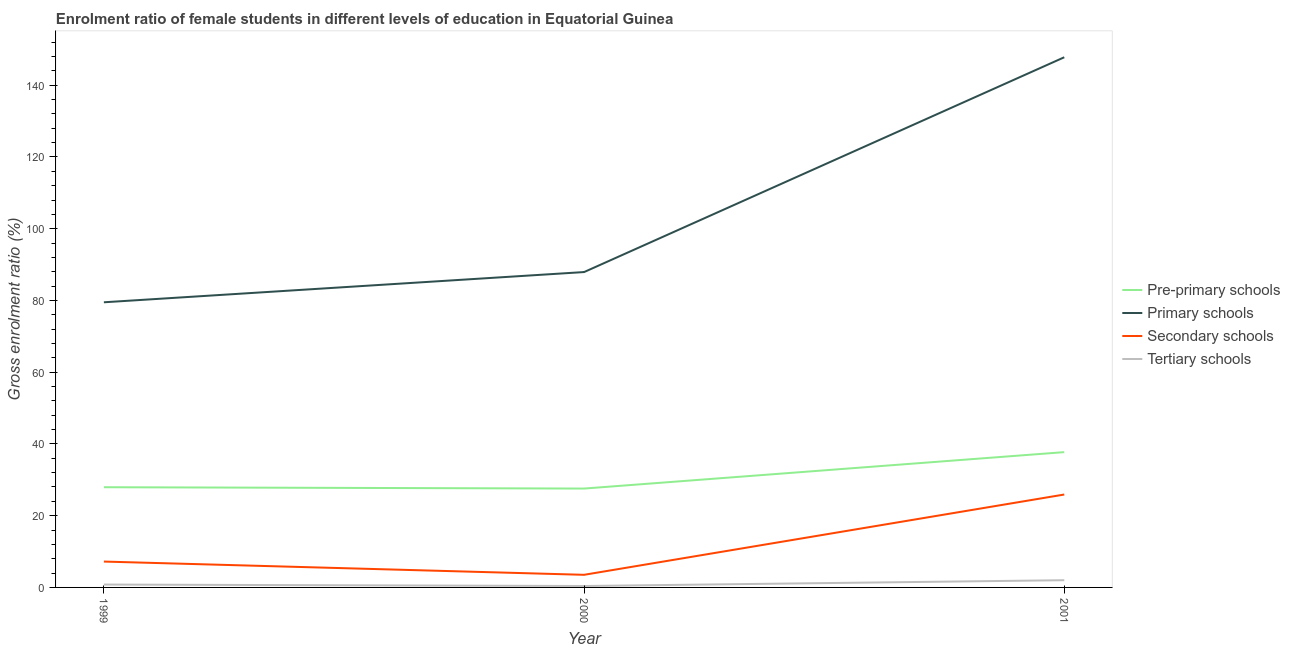What is the gross enrolment ratio(male) in secondary schools in 2000?
Offer a terse response. 3.52. Across all years, what is the maximum gross enrolment ratio(male) in tertiary schools?
Provide a short and direct response. 2.01. Across all years, what is the minimum gross enrolment ratio(male) in secondary schools?
Keep it short and to the point. 3.52. In which year was the gross enrolment ratio(male) in primary schools minimum?
Give a very brief answer. 1999. What is the total gross enrolment ratio(male) in pre-primary schools in the graph?
Keep it short and to the point. 93.21. What is the difference between the gross enrolment ratio(male) in pre-primary schools in 1999 and that in 2000?
Your response must be concise. 0.38. What is the difference between the gross enrolment ratio(male) in secondary schools in 2000 and the gross enrolment ratio(male) in pre-primary schools in 1999?
Keep it short and to the point. -24.42. What is the average gross enrolment ratio(male) in secondary schools per year?
Provide a succinct answer. 12.21. In the year 2001, what is the difference between the gross enrolment ratio(male) in primary schools and gross enrolment ratio(male) in secondary schools?
Offer a terse response. 121.9. In how many years, is the gross enrolment ratio(male) in tertiary schools greater than 136 %?
Ensure brevity in your answer.  0. What is the ratio of the gross enrolment ratio(male) in primary schools in 1999 to that in 2000?
Make the answer very short. 0.9. Is the gross enrolment ratio(male) in secondary schools in 2000 less than that in 2001?
Give a very brief answer. Yes. What is the difference between the highest and the second highest gross enrolment ratio(male) in pre-primary schools?
Your answer should be very brief. 9.78. What is the difference between the highest and the lowest gross enrolment ratio(male) in tertiary schools?
Keep it short and to the point. 1.62. In how many years, is the gross enrolment ratio(male) in secondary schools greater than the average gross enrolment ratio(male) in secondary schools taken over all years?
Ensure brevity in your answer.  1. Is it the case that in every year, the sum of the gross enrolment ratio(male) in primary schools and gross enrolment ratio(male) in secondary schools is greater than the sum of gross enrolment ratio(male) in tertiary schools and gross enrolment ratio(male) in pre-primary schools?
Offer a terse response. Yes. Is it the case that in every year, the sum of the gross enrolment ratio(male) in pre-primary schools and gross enrolment ratio(male) in primary schools is greater than the gross enrolment ratio(male) in secondary schools?
Give a very brief answer. Yes. Is the gross enrolment ratio(male) in tertiary schools strictly less than the gross enrolment ratio(male) in pre-primary schools over the years?
Provide a short and direct response. Yes. How many lines are there?
Your response must be concise. 4. What is the difference between two consecutive major ticks on the Y-axis?
Your answer should be very brief. 20. Does the graph contain any zero values?
Keep it short and to the point. No. How many legend labels are there?
Make the answer very short. 4. What is the title of the graph?
Provide a succinct answer. Enrolment ratio of female students in different levels of education in Equatorial Guinea. Does "Others" appear as one of the legend labels in the graph?
Make the answer very short. No. What is the label or title of the X-axis?
Your answer should be very brief. Year. What is the Gross enrolment ratio (%) in Pre-primary schools in 1999?
Make the answer very short. 27.94. What is the Gross enrolment ratio (%) of Primary schools in 1999?
Your response must be concise. 79.49. What is the Gross enrolment ratio (%) in Secondary schools in 1999?
Give a very brief answer. 7.21. What is the Gross enrolment ratio (%) of Tertiary schools in 1999?
Your answer should be very brief. 0.8. What is the Gross enrolment ratio (%) of Pre-primary schools in 2000?
Keep it short and to the point. 27.56. What is the Gross enrolment ratio (%) in Primary schools in 2000?
Your response must be concise. 87.91. What is the Gross enrolment ratio (%) of Secondary schools in 2000?
Give a very brief answer. 3.52. What is the Gross enrolment ratio (%) of Tertiary schools in 2000?
Offer a terse response. 0.4. What is the Gross enrolment ratio (%) in Pre-primary schools in 2001?
Ensure brevity in your answer.  37.72. What is the Gross enrolment ratio (%) in Primary schools in 2001?
Keep it short and to the point. 147.8. What is the Gross enrolment ratio (%) in Secondary schools in 2001?
Provide a succinct answer. 25.9. What is the Gross enrolment ratio (%) in Tertiary schools in 2001?
Provide a succinct answer. 2.01. Across all years, what is the maximum Gross enrolment ratio (%) of Pre-primary schools?
Make the answer very short. 37.72. Across all years, what is the maximum Gross enrolment ratio (%) in Primary schools?
Your answer should be compact. 147.8. Across all years, what is the maximum Gross enrolment ratio (%) in Secondary schools?
Make the answer very short. 25.9. Across all years, what is the maximum Gross enrolment ratio (%) of Tertiary schools?
Your response must be concise. 2.01. Across all years, what is the minimum Gross enrolment ratio (%) in Pre-primary schools?
Offer a very short reply. 27.56. Across all years, what is the minimum Gross enrolment ratio (%) of Primary schools?
Offer a terse response. 79.49. Across all years, what is the minimum Gross enrolment ratio (%) in Secondary schools?
Ensure brevity in your answer.  3.52. Across all years, what is the minimum Gross enrolment ratio (%) of Tertiary schools?
Give a very brief answer. 0.4. What is the total Gross enrolment ratio (%) in Pre-primary schools in the graph?
Your response must be concise. 93.21. What is the total Gross enrolment ratio (%) of Primary schools in the graph?
Make the answer very short. 315.2. What is the total Gross enrolment ratio (%) of Secondary schools in the graph?
Make the answer very short. 36.62. What is the total Gross enrolment ratio (%) in Tertiary schools in the graph?
Keep it short and to the point. 3.21. What is the difference between the Gross enrolment ratio (%) in Pre-primary schools in 1999 and that in 2000?
Keep it short and to the point. 0.38. What is the difference between the Gross enrolment ratio (%) of Primary schools in 1999 and that in 2000?
Provide a succinct answer. -8.42. What is the difference between the Gross enrolment ratio (%) in Secondary schools in 1999 and that in 2000?
Make the answer very short. 3.69. What is the difference between the Gross enrolment ratio (%) in Tertiary schools in 1999 and that in 2000?
Provide a short and direct response. 0.4. What is the difference between the Gross enrolment ratio (%) of Pre-primary schools in 1999 and that in 2001?
Offer a terse response. -9.78. What is the difference between the Gross enrolment ratio (%) of Primary schools in 1999 and that in 2001?
Give a very brief answer. -68.31. What is the difference between the Gross enrolment ratio (%) in Secondary schools in 1999 and that in 2001?
Provide a succinct answer. -18.69. What is the difference between the Gross enrolment ratio (%) in Tertiary schools in 1999 and that in 2001?
Make the answer very short. -1.21. What is the difference between the Gross enrolment ratio (%) in Pre-primary schools in 2000 and that in 2001?
Ensure brevity in your answer.  -10.16. What is the difference between the Gross enrolment ratio (%) of Primary schools in 2000 and that in 2001?
Make the answer very short. -59.88. What is the difference between the Gross enrolment ratio (%) in Secondary schools in 2000 and that in 2001?
Give a very brief answer. -22.38. What is the difference between the Gross enrolment ratio (%) in Tertiary schools in 2000 and that in 2001?
Give a very brief answer. -1.62. What is the difference between the Gross enrolment ratio (%) of Pre-primary schools in 1999 and the Gross enrolment ratio (%) of Primary schools in 2000?
Your answer should be compact. -59.98. What is the difference between the Gross enrolment ratio (%) in Pre-primary schools in 1999 and the Gross enrolment ratio (%) in Secondary schools in 2000?
Offer a very short reply. 24.42. What is the difference between the Gross enrolment ratio (%) in Pre-primary schools in 1999 and the Gross enrolment ratio (%) in Tertiary schools in 2000?
Provide a short and direct response. 27.54. What is the difference between the Gross enrolment ratio (%) of Primary schools in 1999 and the Gross enrolment ratio (%) of Secondary schools in 2000?
Provide a succinct answer. 75.97. What is the difference between the Gross enrolment ratio (%) in Primary schools in 1999 and the Gross enrolment ratio (%) in Tertiary schools in 2000?
Give a very brief answer. 79.09. What is the difference between the Gross enrolment ratio (%) of Secondary schools in 1999 and the Gross enrolment ratio (%) of Tertiary schools in 2000?
Provide a succinct answer. 6.81. What is the difference between the Gross enrolment ratio (%) of Pre-primary schools in 1999 and the Gross enrolment ratio (%) of Primary schools in 2001?
Ensure brevity in your answer.  -119.86. What is the difference between the Gross enrolment ratio (%) in Pre-primary schools in 1999 and the Gross enrolment ratio (%) in Secondary schools in 2001?
Keep it short and to the point. 2.04. What is the difference between the Gross enrolment ratio (%) in Pre-primary schools in 1999 and the Gross enrolment ratio (%) in Tertiary schools in 2001?
Provide a short and direct response. 25.92. What is the difference between the Gross enrolment ratio (%) in Primary schools in 1999 and the Gross enrolment ratio (%) in Secondary schools in 2001?
Keep it short and to the point. 53.59. What is the difference between the Gross enrolment ratio (%) of Primary schools in 1999 and the Gross enrolment ratio (%) of Tertiary schools in 2001?
Offer a terse response. 77.48. What is the difference between the Gross enrolment ratio (%) of Secondary schools in 1999 and the Gross enrolment ratio (%) of Tertiary schools in 2001?
Your answer should be very brief. 5.19. What is the difference between the Gross enrolment ratio (%) in Pre-primary schools in 2000 and the Gross enrolment ratio (%) in Primary schools in 2001?
Keep it short and to the point. -120.24. What is the difference between the Gross enrolment ratio (%) of Pre-primary schools in 2000 and the Gross enrolment ratio (%) of Secondary schools in 2001?
Your answer should be compact. 1.66. What is the difference between the Gross enrolment ratio (%) of Pre-primary schools in 2000 and the Gross enrolment ratio (%) of Tertiary schools in 2001?
Make the answer very short. 25.55. What is the difference between the Gross enrolment ratio (%) in Primary schools in 2000 and the Gross enrolment ratio (%) in Secondary schools in 2001?
Ensure brevity in your answer.  62.02. What is the difference between the Gross enrolment ratio (%) of Primary schools in 2000 and the Gross enrolment ratio (%) of Tertiary schools in 2001?
Keep it short and to the point. 85.9. What is the difference between the Gross enrolment ratio (%) in Secondary schools in 2000 and the Gross enrolment ratio (%) in Tertiary schools in 2001?
Keep it short and to the point. 1.5. What is the average Gross enrolment ratio (%) of Pre-primary schools per year?
Your response must be concise. 31.07. What is the average Gross enrolment ratio (%) of Primary schools per year?
Ensure brevity in your answer.  105.07. What is the average Gross enrolment ratio (%) in Secondary schools per year?
Your answer should be compact. 12.21. What is the average Gross enrolment ratio (%) of Tertiary schools per year?
Offer a terse response. 1.07. In the year 1999, what is the difference between the Gross enrolment ratio (%) of Pre-primary schools and Gross enrolment ratio (%) of Primary schools?
Give a very brief answer. -51.55. In the year 1999, what is the difference between the Gross enrolment ratio (%) in Pre-primary schools and Gross enrolment ratio (%) in Secondary schools?
Your answer should be very brief. 20.73. In the year 1999, what is the difference between the Gross enrolment ratio (%) of Pre-primary schools and Gross enrolment ratio (%) of Tertiary schools?
Offer a terse response. 27.14. In the year 1999, what is the difference between the Gross enrolment ratio (%) in Primary schools and Gross enrolment ratio (%) in Secondary schools?
Ensure brevity in your answer.  72.28. In the year 1999, what is the difference between the Gross enrolment ratio (%) of Primary schools and Gross enrolment ratio (%) of Tertiary schools?
Provide a succinct answer. 78.69. In the year 1999, what is the difference between the Gross enrolment ratio (%) in Secondary schools and Gross enrolment ratio (%) in Tertiary schools?
Your answer should be very brief. 6.41. In the year 2000, what is the difference between the Gross enrolment ratio (%) in Pre-primary schools and Gross enrolment ratio (%) in Primary schools?
Your answer should be compact. -60.35. In the year 2000, what is the difference between the Gross enrolment ratio (%) of Pre-primary schools and Gross enrolment ratio (%) of Secondary schools?
Offer a very short reply. 24.04. In the year 2000, what is the difference between the Gross enrolment ratio (%) of Pre-primary schools and Gross enrolment ratio (%) of Tertiary schools?
Keep it short and to the point. 27.16. In the year 2000, what is the difference between the Gross enrolment ratio (%) of Primary schools and Gross enrolment ratio (%) of Secondary schools?
Your answer should be compact. 84.4. In the year 2000, what is the difference between the Gross enrolment ratio (%) of Primary schools and Gross enrolment ratio (%) of Tertiary schools?
Keep it short and to the point. 87.52. In the year 2000, what is the difference between the Gross enrolment ratio (%) in Secondary schools and Gross enrolment ratio (%) in Tertiary schools?
Offer a very short reply. 3.12. In the year 2001, what is the difference between the Gross enrolment ratio (%) of Pre-primary schools and Gross enrolment ratio (%) of Primary schools?
Your answer should be compact. -110.08. In the year 2001, what is the difference between the Gross enrolment ratio (%) of Pre-primary schools and Gross enrolment ratio (%) of Secondary schools?
Make the answer very short. 11.82. In the year 2001, what is the difference between the Gross enrolment ratio (%) of Pre-primary schools and Gross enrolment ratio (%) of Tertiary schools?
Offer a very short reply. 35.7. In the year 2001, what is the difference between the Gross enrolment ratio (%) in Primary schools and Gross enrolment ratio (%) in Secondary schools?
Offer a very short reply. 121.9. In the year 2001, what is the difference between the Gross enrolment ratio (%) of Primary schools and Gross enrolment ratio (%) of Tertiary schools?
Your answer should be very brief. 145.78. In the year 2001, what is the difference between the Gross enrolment ratio (%) in Secondary schools and Gross enrolment ratio (%) in Tertiary schools?
Offer a very short reply. 23.88. What is the ratio of the Gross enrolment ratio (%) in Pre-primary schools in 1999 to that in 2000?
Ensure brevity in your answer.  1.01. What is the ratio of the Gross enrolment ratio (%) in Primary schools in 1999 to that in 2000?
Ensure brevity in your answer.  0.9. What is the ratio of the Gross enrolment ratio (%) in Secondary schools in 1999 to that in 2000?
Make the answer very short. 2.05. What is the ratio of the Gross enrolment ratio (%) in Tertiary schools in 1999 to that in 2000?
Give a very brief answer. 2.01. What is the ratio of the Gross enrolment ratio (%) of Pre-primary schools in 1999 to that in 2001?
Offer a very short reply. 0.74. What is the ratio of the Gross enrolment ratio (%) of Primary schools in 1999 to that in 2001?
Ensure brevity in your answer.  0.54. What is the ratio of the Gross enrolment ratio (%) in Secondary schools in 1999 to that in 2001?
Provide a succinct answer. 0.28. What is the ratio of the Gross enrolment ratio (%) in Tertiary schools in 1999 to that in 2001?
Make the answer very short. 0.4. What is the ratio of the Gross enrolment ratio (%) of Pre-primary schools in 2000 to that in 2001?
Keep it short and to the point. 0.73. What is the ratio of the Gross enrolment ratio (%) in Primary schools in 2000 to that in 2001?
Your answer should be compact. 0.59. What is the ratio of the Gross enrolment ratio (%) of Secondary schools in 2000 to that in 2001?
Your response must be concise. 0.14. What is the ratio of the Gross enrolment ratio (%) of Tertiary schools in 2000 to that in 2001?
Your answer should be very brief. 0.2. What is the difference between the highest and the second highest Gross enrolment ratio (%) of Pre-primary schools?
Make the answer very short. 9.78. What is the difference between the highest and the second highest Gross enrolment ratio (%) in Primary schools?
Give a very brief answer. 59.88. What is the difference between the highest and the second highest Gross enrolment ratio (%) in Secondary schools?
Your answer should be very brief. 18.69. What is the difference between the highest and the second highest Gross enrolment ratio (%) of Tertiary schools?
Your answer should be compact. 1.21. What is the difference between the highest and the lowest Gross enrolment ratio (%) in Pre-primary schools?
Your answer should be very brief. 10.16. What is the difference between the highest and the lowest Gross enrolment ratio (%) in Primary schools?
Your answer should be very brief. 68.31. What is the difference between the highest and the lowest Gross enrolment ratio (%) in Secondary schools?
Give a very brief answer. 22.38. What is the difference between the highest and the lowest Gross enrolment ratio (%) of Tertiary schools?
Give a very brief answer. 1.62. 